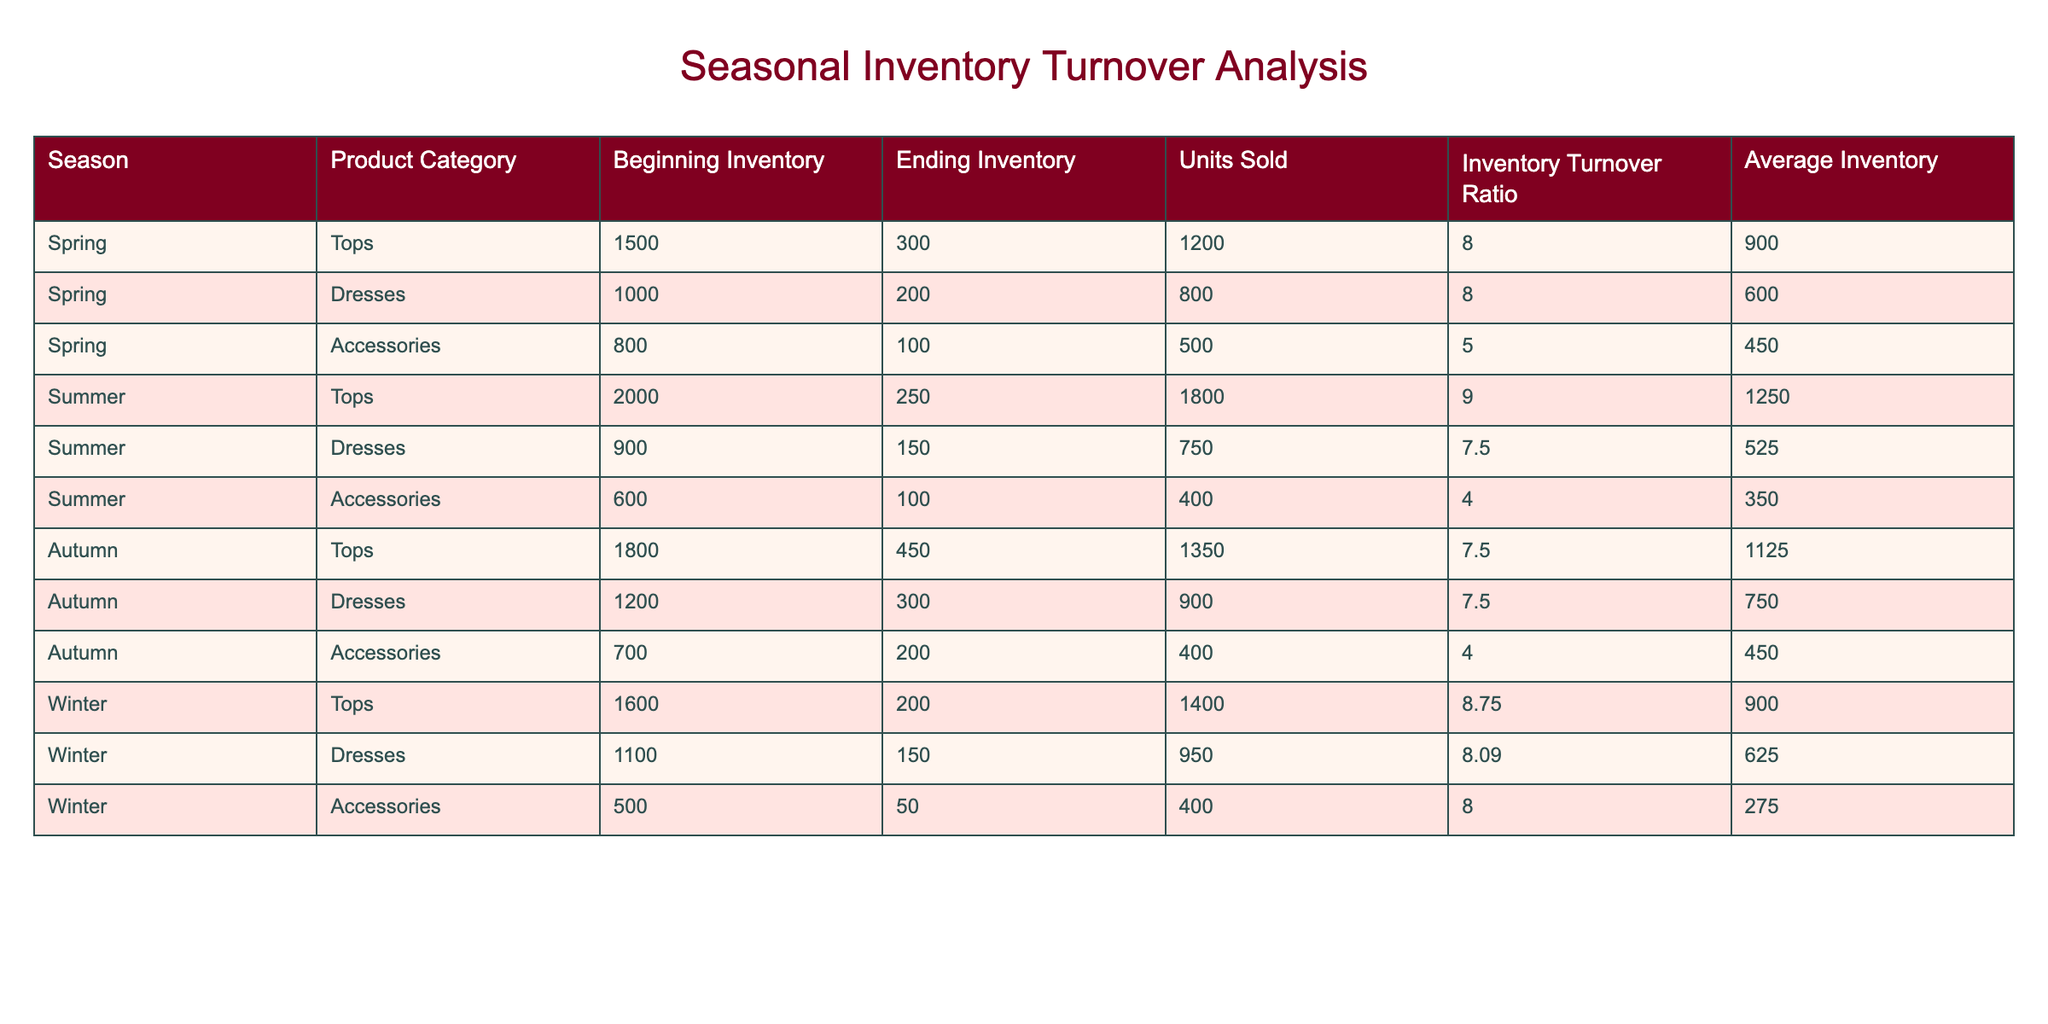What is the Inventory Turnover Ratio for Summer Dresses? The Inventory Turnover Ratio for Summer Dresses is listed in the table under that specific category. The value is 7.50.
Answer: 7.50 Which product category had the lowest Ending Inventory in Spring? To find the product category with the lowest Ending Inventory in Spring, we can compare the values for Tops, Dresses, and Accessories. The Ending Inventory values are 300, 200, and 100 respectively. Accessories has the lowest Ending Inventory at 100.
Answer: Accessories What is the total Units Sold for Autumn Tops and Dresses? To calculate the total Units Sold for Autumn Tops and Dresses, we find the Units Sold for each category: Tops has 1350 and Dresses has 900. Adding these together gives 1350 + 900 = 2250.
Answer: 2250 During which season did Accessories have the highest Inventory Turnover Ratio? By comparing the Inventory Turnover Ratios for Accessories across all seasons (5.00 in Spring, 4.00 in Summer, 4.00 in Autumn, and 8.00 in Winter), we see that Winter has the highest ratio at 8.00.
Answer: Winter Is the Average Inventory for Summer Tops greater than that for Spring Tops? From the table, the Average Inventory for Summer Tops is 1250 and for Spring Tops it is 900. Since 1250 is greater than 900, the statement is true.
Answer: Yes Which season and product category combination has the highest Units Sold? We need to review the Units Sold across all categories and seasons. The highest value is 1800 for Summer Tops. Thus, the combination is Summer Tops.
Answer: Summer Tops What is the average Units Sold for the Accessories category across all seasons? To find the average, we first sum the Units Sold for Accessories: 500 (Spring) + 400 (Summer) + 400 (Autumn) + 400 (Winter) = 1700. There are 4 seasons, so we divide 1700 by 4 to get 425.
Answer: 425 How much did the Ending Inventory drop for Tops from Spring to Winter? To find the drop in Ending Inventory, we subtract the Ending Inventory for Winter Tops (200) from Spring Tops (300): 300 - 200 = 100.
Answer: 100 Which season had the highest Average Inventory for Dresses? Comparing the Average Inventory values for Dresses: 600 (Spring), 525 (Summer), 750 (Autumn), and 625 (Winter), the highest is 750 in Autumn.
Answer: Autumn 